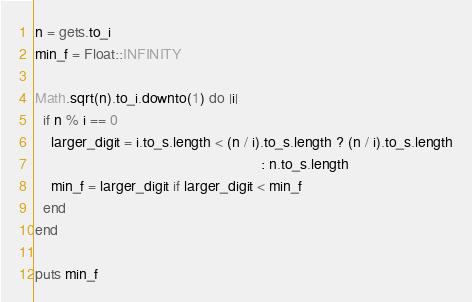<code> <loc_0><loc_0><loc_500><loc_500><_Ruby_>n = gets.to_i
min_f = Float::INFINITY

Math.sqrt(n).to_i.downto(1) do |i|
  if n % i == 0
    larger_digit = i.to_s.length < (n / i).to_s.length ? (n / i).to_s.length
                                                       : n.to_s.length
    min_f = larger_digit if larger_digit < min_f
  end
end

puts min_f</code> 